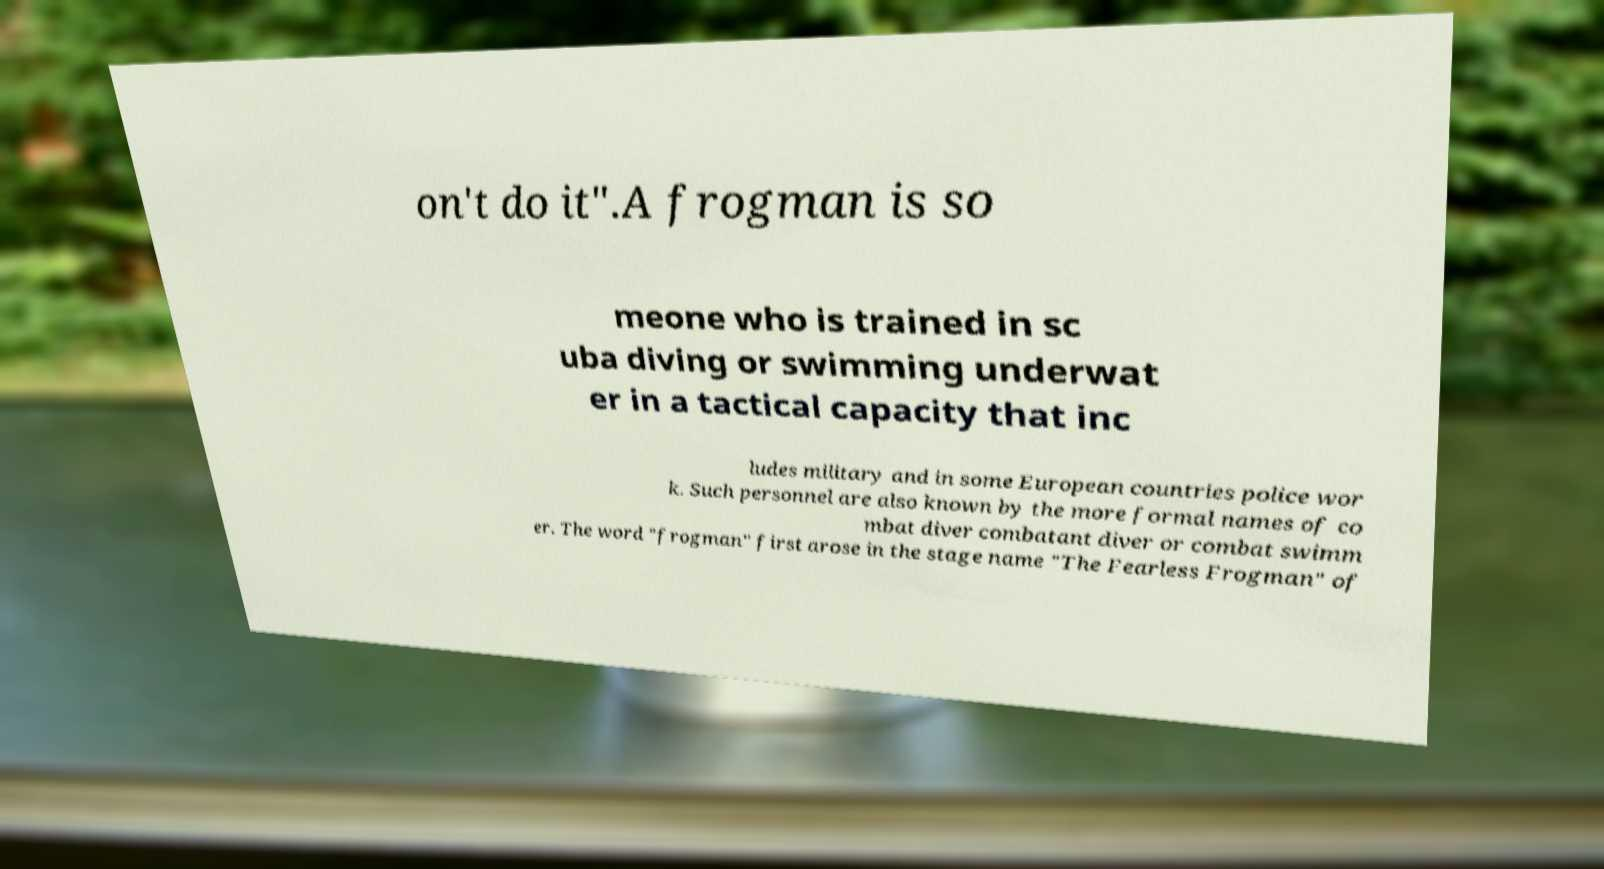Please identify and transcribe the text found in this image. on't do it".A frogman is so meone who is trained in sc uba diving or swimming underwat er in a tactical capacity that inc ludes military and in some European countries police wor k. Such personnel are also known by the more formal names of co mbat diver combatant diver or combat swimm er. The word "frogman" first arose in the stage name "The Fearless Frogman" of 